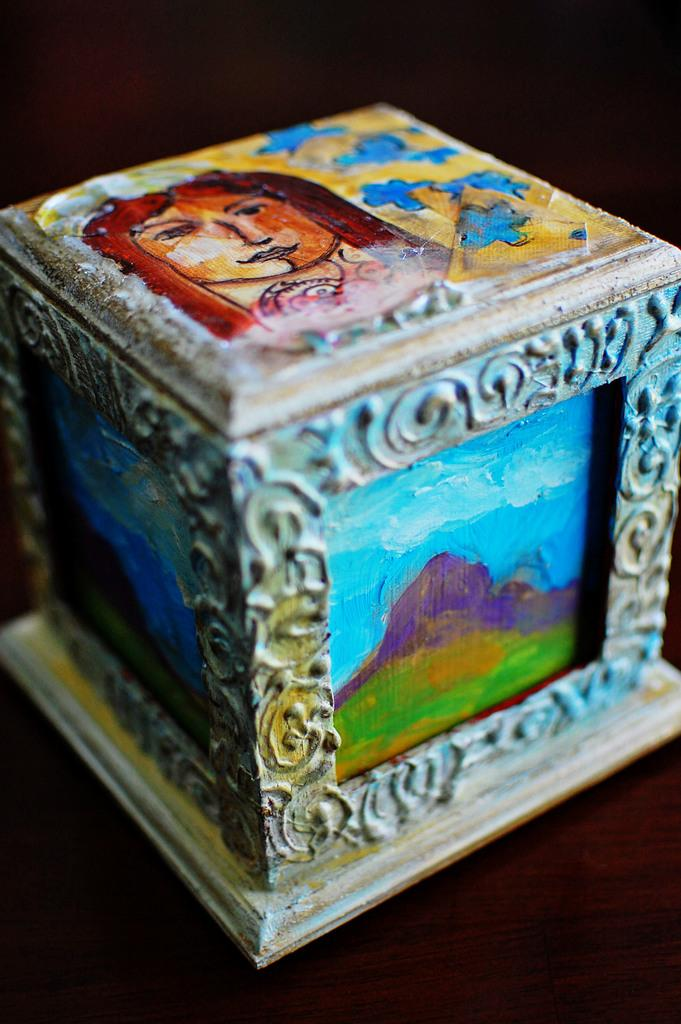What objects are present in the image? There are boxes in the image. What is depicted on the faces of the boxes? Each face of the boxes has something painted on it. What can be observed about the overall appearance of the image? The background of the image is dark. What type of crayon is being used to draw on the boxes in the image? There is no crayon present in the image; the faces of the boxes have something painted on them. How does the drum sound in the image? There is no drum present in the image. 